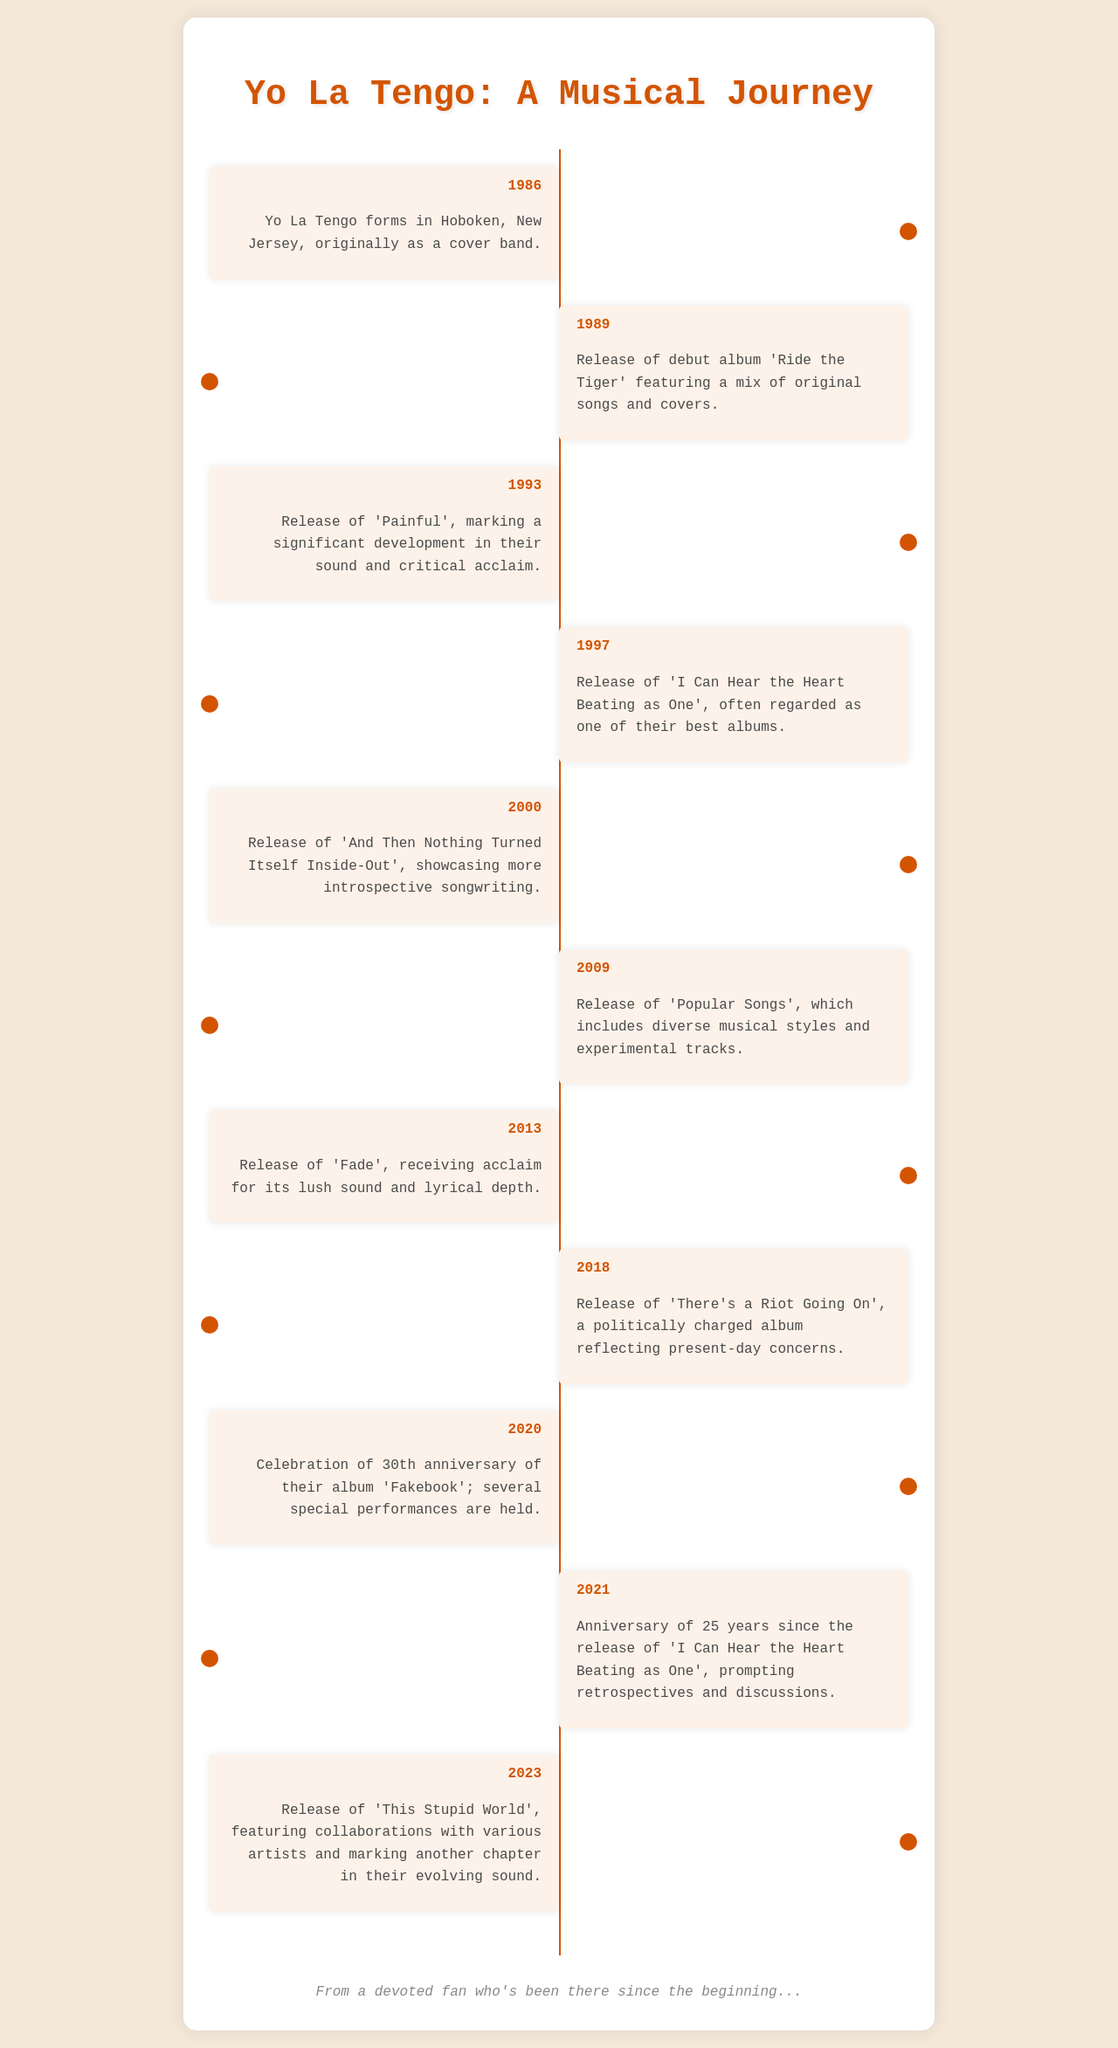What year was Yo La Tengo formed? The document states that Yo La Tengo formed in 1986.
Answer: 1986 What is the title of their debut album? According to the timeline, their debut album released in 1989 is titled 'Ride the Tiger'.
Answer: 'Ride the Tiger' Which album is often regarded as one of their best? The document mentions that 'I Can Hear the Heart Beating as One' is often regarded as one of their best albums, released in 1997.
Answer: 'I Can Hear the Heart Beating as One' How many years passed between the release of 'Fakebook' and its 30th anniversary celebration? The timeline indicates that 'Fakebook' was celebrated on its 30th anniversary in 2020, having originally been released in 1990. Thus, 30 years passed.
Answer: 30 What year did they release 'This Stupid World'? The document notes that 'This Stupid World' was released in 2023.
Answer: 2023 Which album released in 2000 showcased more introspective songwriting? The document states that 'And Then Nothing Turned Itself Inside-Out' released in 2000 showcased more introspective songwriting.
Answer: 'And Then Nothing Turned Itself Inside-Out' What significant event occurred in 2013? In 2013, Yo La Tengo released 'Fade', which received acclaim for its lush sound and lyrical depth.
Answer: 'Fade' What type of music styles does 'Popular Songs' include? The timeline describes 'Popular Songs' as including diverse musical styles and experimental tracks, released in 2009.
Answer: diverse musical styles and experimental tracks What anniversary was celebrated in 2021? The document mentions the 25th anniversary of 'I Can Hear the Heart Beating as One' was marked in 2021.
Answer: 25th anniversary 